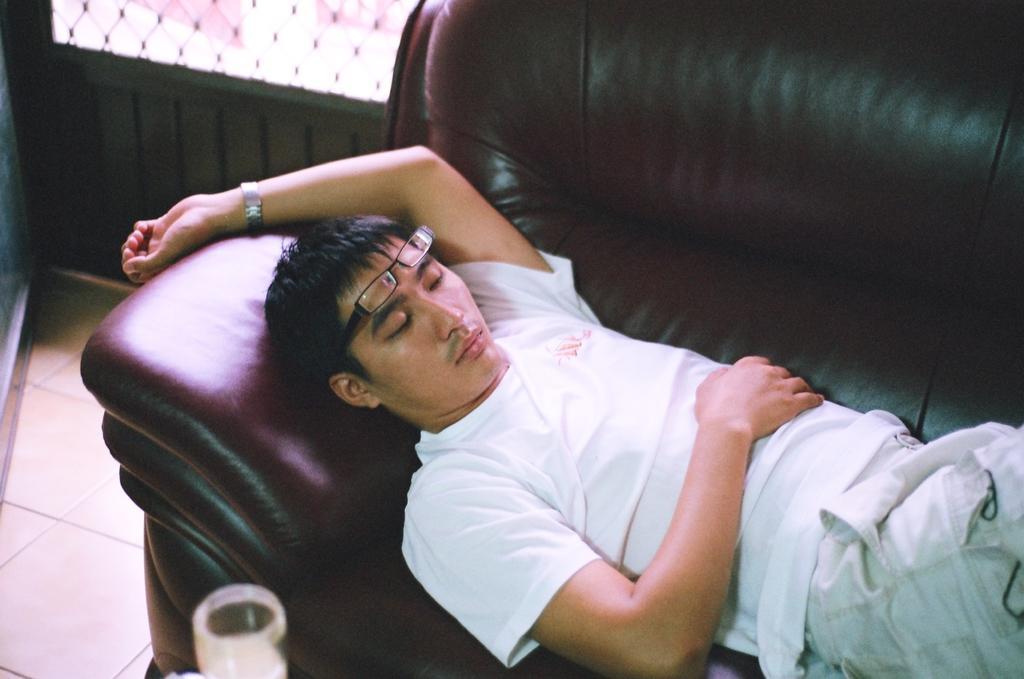Can you describe this image briefly? In this picture we can see a man is sleeping on a sofa, he wore spectacles and a watch, at the bottom there is a glass, we can see a window in the background. 